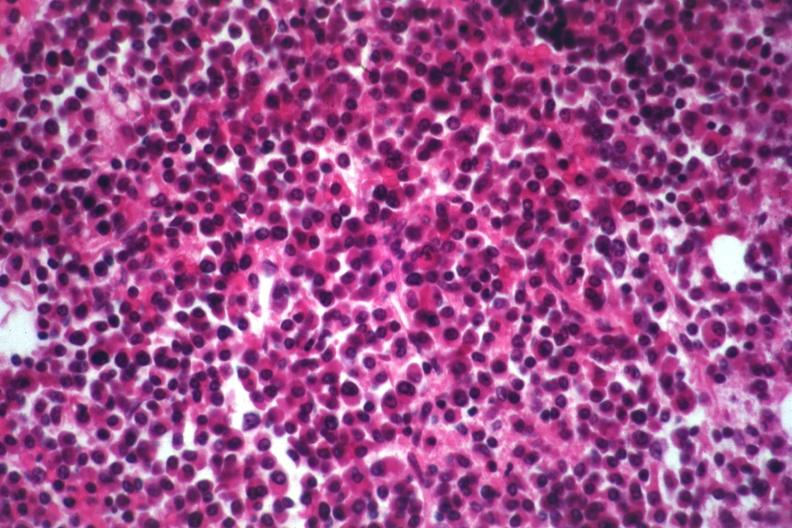s heel ulcer present?
Answer the question using a single word or phrase. No 